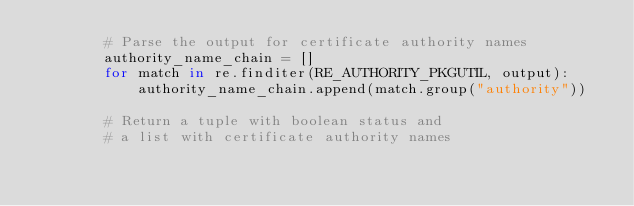Convert code to text. <code><loc_0><loc_0><loc_500><loc_500><_Python_>        # Parse the output for certificate authority names
        authority_name_chain = []
        for match in re.finditer(RE_AUTHORITY_PKGUTIL, output):
            authority_name_chain.append(match.group("authority"))

        # Return a tuple with boolean status and
        # a list with certificate authority names</code> 